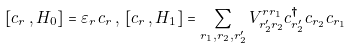<formula> <loc_0><loc_0><loc_500><loc_500>[ c _ { r } \, , H _ { 0 } ] = \varepsilon _ { r } \, c _ { r } \, , \, [ c _ { r } \, , H _ { 1 } ] = \sum _ { r _ { 1 } , r _ { 2 } , r ^ { \prime } _ { 2 } } V ^ { r r _ { 1 } } _ { r ^ { \prime } _ { 2 } r _ { 2 } } c ^ { \dagger } _ { r ^ { \prime } _ { 2 } } c _ { r _ { 2 } } c _ { r _ { 1 } }</formula> 